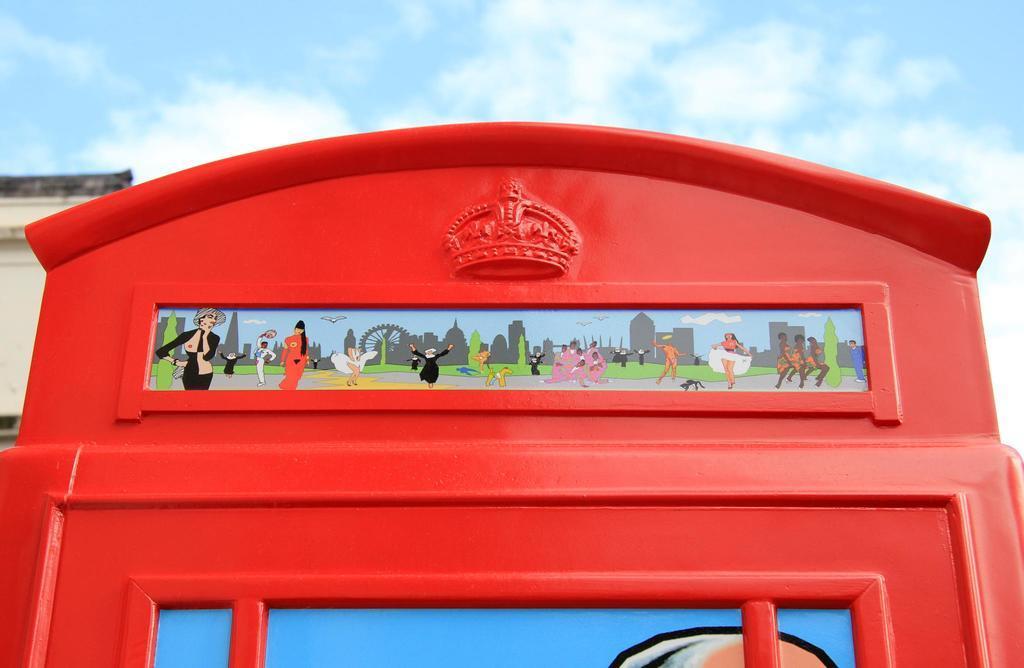How would you summarize this image in a sentence or two? Here we can see an architecture which is in red color and there are cartoon images. In the background we can see sky. 